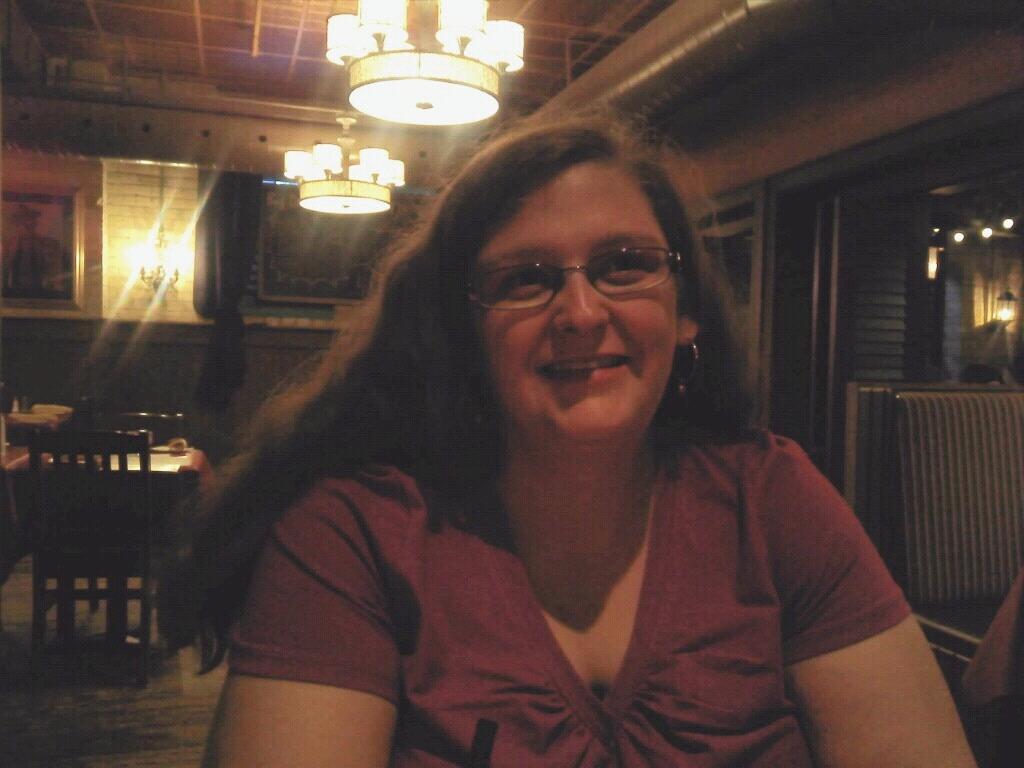In one or two sentences, can you explain what this image depicts? In this image I can see a woman is smiling, she wore top. On the left side there are dining chairs and dining table, at the top there are lights. On the right side there is the glass wall. 